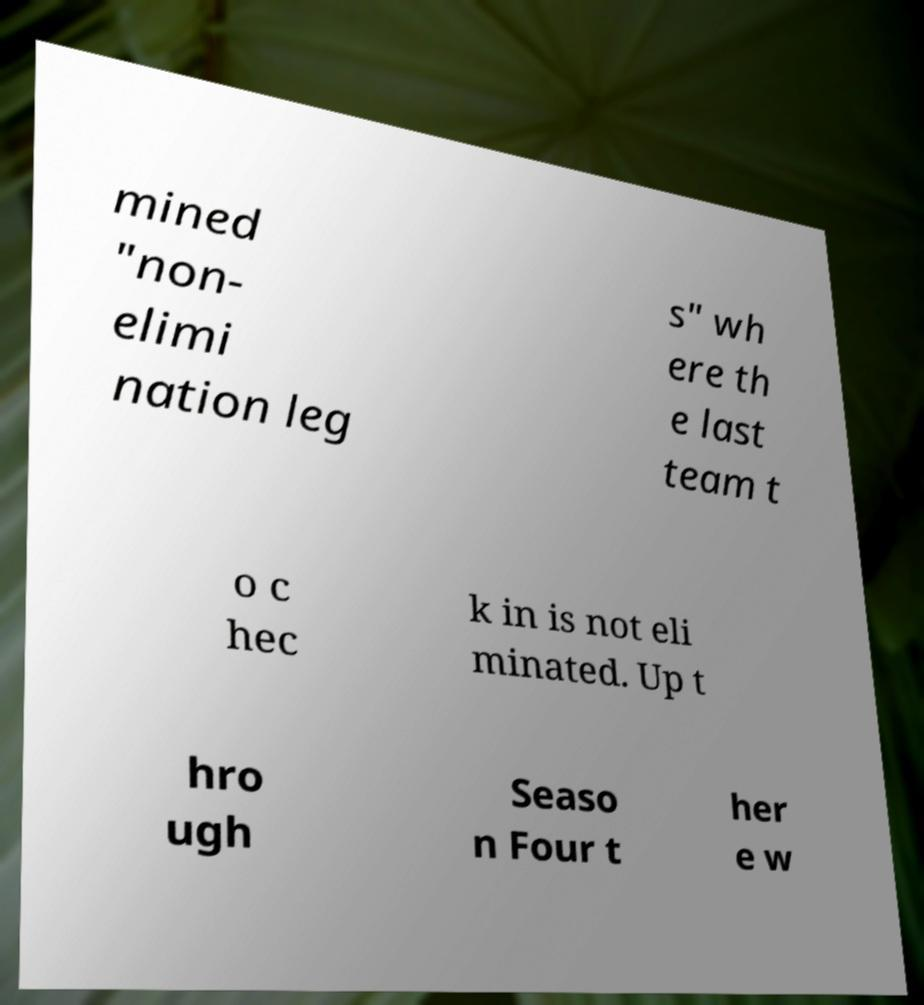Could you extract and type out the text from this image? mined "non- elimi nation leg s" wh ere th e last team t o c hec k in is not eli minated. Up t hro ugh Seaso n Four t her e w 